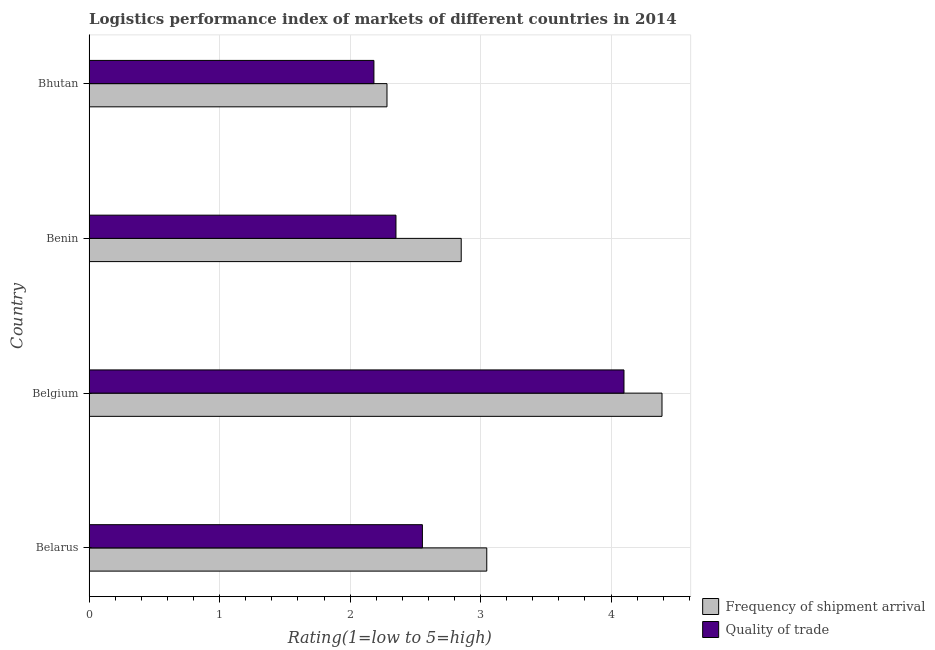How many different coloured bars are there?
Your response must be concise. 2. How many groups of bars are there?
Offer a terse response. 4. How many bars are there on the 3rd tick from the top?
Your response must be concise. 2. How many bars are there on the 3rd tick from the bottom?
Provide a succinct answer. 2. What is the label of the 2nd group of bars from the top?
Provide a short and direct response. Benin. In how many cases, is the number of bars for a given country not equal to the number of legend labels?
Provide a succinct answer. 0. What is the lpi quality of trade in Belgium?
Give a very brief answer. 4.1. Across all countries, what is the maximum lpi of frequency of shipment arrival?
Offer a terse response. 4.39. Across all countries, what is the minimum lpi quality of trade?
Your answer should be very brief. 2.18. In which country was the lpi quality of trade maximum?
Provide a short and direct response. Belgium. In which country was the lpi of frequency of shipment arrival minimum?
Ensure brevity in your answer.  Bhutan. What is the total lpi quality of trade in the graph?
Provide a short and direct response. 11.19. What is the difference between the lpi quality of trade in Belarus and that in Benin?
Your response must be concise. 0.2. What is the difference between the lpi of frequency of shipment arrival in Belgium and the lpi quality of trade in Belarus?
Make the answer very short. 1.84. What is the average lpi quality of trade per country?
Keep it short and to the point. 2.8. What is the ratio of the lpi quality of trade in Belgium to that in Bhutan?
Provide a short and direct response. 1.88. Is the lpi quality of trade in Belarus less than that in Bhutan?
Give a very brief answer. No. Is the difference between the lpi of frequency of shipment arrival in Belarus and Benin greater than the difference between the lpi quality of trade in Belarus and Benin?
Provide a short and direct response. No. What is the difference between the highest and the second highest lpi quality of trade?
Your answer should be compact. 1.54. What is the difference between the highest and the lowest lpi of frequency of shipment arrival?
Your response must be concise. 2.11. What does the 1st bar from the top in Belgium represents?
Keep it short and to the point. Quality of trade. What does the 2nd bar from the bottom in Belarus represents?
Ensure brevity in your answer.  Quality of trade. Are all the bars in the graph horizontal?
Offer a very short reply. Yes. How many countries are there in the graph?
Keep it short and to the point. 4. What is the difference between two consecutive major ticks on the X-axis?
Provide a succinct answer. 1. Are the values on the major ticks of X-axis written in scientific E-notation?
Your answer should be compact. No. Does the graph contain grids?
Your answer should be compact. Yes. Where does the legend appear in the graph?
Keep it short and to the point. Bottom right. How many legend labels are there?
Your answer should be compact. 2. How are the legend labels stacked?
Offer a terse response. Vertical. What is the title of the graph?
Your response must be concise. Logistics performance index of markets of different countries in 2014. What is the label or title of the X-axis?
Your answer should be very brief. Rating(1=low to 5=high). What is the Rating(1=low to 5=high) in Frequency of shipment arrival in Belarus?
Keep it short and to the point. 3.05. What is the Rating(1=low to 5=high) of Quality of trade in Belarus?
Provide a succinct answer. 2.55. What is the Rating(1=low to 5=high) in Frequency of shipment arrival in Belgium?
Ensure brevity in your answer.  4.39. What is the Rating(1=low to 5=high) of Quality of trade in Belgium?
Offer a very short reply. 4.1. What is the Rating(1=low to 5=high) of Frequency of shipment arrival in Benin?
Provide a succinct answer. 2.85. What is the Rating(1=low to 5=high) in Quality of trade in Benin?
Offer a terse response. 2.35. What is the Rating(1=low to 5=high) in Frequency of shipment arrival in Bhutan?
Your answer should be compact. 2.28. What is the Rating(1=low to 5=high) of Quality of trade in Bhutan?
Your answer should be very brief. 2.18. Across all countries, what is the maximum Rating(1=low to 5=high) of Frequency of shipment arrival?
Offer a very short reply. 4.39. Across all countries, what is the maximum Rating(1=low to 5=high) in Quality of trade?
Offer a very short reply. 4.1. Across all countries, what is the minimum Rating(1=low to 5=high) in Frequency of shipment arrival?
Give a very brief answer. 2.28. Across all countries, what is the minimum Rating(1=low to 5=high) of Quality of trade?
Your answer should be very brief. 2.18. What is the total Rating(1=low to 5=high) of Frequency of shipment arrival in the graph?
Offer a terse response. 12.57. What is the total Rating(1=low to 5=high) in Quality of trade in the graph?
Your answer should be compact. 11.19. What is the difference between the Rating(1=low to 5=high) in Frequency of shipment arrival in Belarus and that in Belgium?
Provide a short and direct response. -1.34. What is the difference between the Rating(1=low to 5=high) in Quality of trade in Belarus and that in Belgium?
Provide a short and direct response. -1.54. What is the difference between the Rating(1=low to 5=high) in Frequency of shipment arrival in Belarus and that in Benin?
Your answer should be compact. 0.2. What is the difference between the Rating(1=low to 5=high) in Quality of trade in Belarus and that in Benin?
Ensure brevity in your answer.  0.2. What is the difference between the Rating(1=low to 5=high) in Frequency of shipment arrival in Belarus and that in Bhutan?
Your answer should be compact. 0.76. What is the difference between the Rating(1=low to 5=high) of Quality of trade in Belarus and that in Bhutan?
Give a very brief answer. 0.37. What is the difference between the Rating(1=low to 5=high) of Frequency of shipment arrival in Belgium and that in Benin?
Your response must be concise. 1.54. What is the difference between the Rating(1=low to 5=high) in Quality of trade in Belgium and that in Benin?
Your response must be concise. 1.75. What is the difference between the Rating(1=low to 5=high) in Frequency of shipment arrival in Belgium and that in Bhutan?
Offer a terse response. 2.11. What is the difference between the Rating(1=low to 5=high) in Quality of trade in Belgium and that in Bhutan?
Make the answer very short. 1.92. What is the difference between the Rating(1=low to 5=high) in Frequency of shipment arrival in Benin and that in Bhutan?
Provide a short and direct response. 0.57. What is the difference between the Rating(1=low to 5=high) of Quality of trade in Benin and that in Bhutan?
Offer a terse response. 0.17. What is the difference between the Rating(1=low to 5=high) in Frequency of shipment arrival in Belarus and the Rating(1=low to 5=high) in Quality of trade in Belgium?
Offer a terse response. -1.05. What is the difference between the Rating(1=low to 5=high) in Frequency of shipment arrival in Belarus and the Rating(1=low to 5=high) in Quality of trade in Benin?
Ensure brevity in your answer.  0.7. What is the difference between the Rating(1=low to 5=high) of Frequency of shipment arrival in Belarus and the Rating(1=low to 5=high) of Quality of trade in Bhutan?
Your response must be concise. 0.86. What is the difference between the Rating(1=low to 5=high) in Frequency of shipment arrival in Belgium and the Rating(1=low to 5=high) in Quality of trade in Benin?
Make the answer very short. 2.04. What is the difference between the Rating(1=low to 5=high) of Frequency of shipment arrival in Belgium and the Rating(1=low to 5=high) of Quality of trade in Bhutan?
Ensure brevity in your answer.  2.21. What is the difference between the Rating(1=low to 5=high) of Frequency of shipment arrival in Benin and the Rating(1=low to 5=high) of Quality of trade in Bhutan?
Ensure brevity in your answer.  0.67. What is the average Rating(1=low to 5=high) of Frequency of shipment arrival per country?
Your response must be concise. 3.14. What is the average Rating(1=low to 5=high) of Quality of trade per country?
Your answer should be very brief. 2.8. What is the difference between the Rating(1=low to 5=high) of Frequency of shipment arrival and Rating(1=low to 5=high) of Quality of trade in Belarus?
Give a very brief answer. 0.49. What is the difference between the Rating(1=low to 5=high) in Frequency of shipment arrival and Rating(1=low to 5=high) in Quality of trade in Belgium?
Give a very brief answer. 0.29. What is the ratio of the Rating(1=low to 5=high) of Frequency of shipment arrival in Belarus to that in Belgium?
Make the answer very short. 0.69. What is the ratio of the Rating(1=low to 5=high) in Quality of trade in Belarus to that in Belgium?
Offer a very short reply. 0.62. What is the ratio of the Rating(1=low to 5=high) of Frequency of shipment arrival in Belarus to that in Benin?
Provide a succinct answer. 1.07. What is the ratio of the Rating(1=low to 5=high) in Quality of trade in Belarus to that in Benin?
Offer a terse response. 1.09. What is the ratio of the Rating(1=low to 5=high) in Frequency of shipment arrival in Belarus to that in Bhutan?
Provide a succinct answer. 1.33. What is the ratio of the Rating(1=low to 5=high) in Quality of trade in Belarus to that in Bhutan?
Offer a very short reply. 1.17. What is the ratio of the Rating(1=low to 5=high) of Frequency of shipment arrival in Belgium to that in Benin?
Ensure brevity in your answer.  1.54. What is the ratio of the Rating(1=low to 5=high) of Quality of trade in Belgium to that in Benin?
Your answer should be compact. 1.74. What is the ratio of the Rating(1=low to 5=high) in Frequency of shipment arrival in Belgium to that in Bhutan?
Your answer should be very brief. 1.92. What is the ratio of the Rating(1=low to 5=high) in Quality of trade in Belgium to that in Bhutan?
Ensure brevity in your answer.  1.88. What is the ratio of the Rating(1=low to 5=high) in Frequency of shipment arrival in Benin to that in Bhutan?
Provide a succinct answer. 1.25. What is the ratio of the Rating(1=low to 5=high) of Quality of trade in Benin to that in Bhutan?
Your answer should be compact. 1.08. What is the difference between the highest and the second highest Rating(1=low to 5=high) in Frequency of shipment arrival?
Make the answer very short. 1.34. What is the difference between the highest and the second highest Rating(1=low to 5=high) of Quality of trade?
Provide a succinct answer. 1.54. What is the difference between the highest and the lowest Rating(1=low to 5=high) of Frequency of shipment arrival?
Offer a very short reply. 2.11. What is the difference between the highest and the lowest Rating(1=low to 5=high) in Quality of trade?
Make the answer very short. 1.92. 